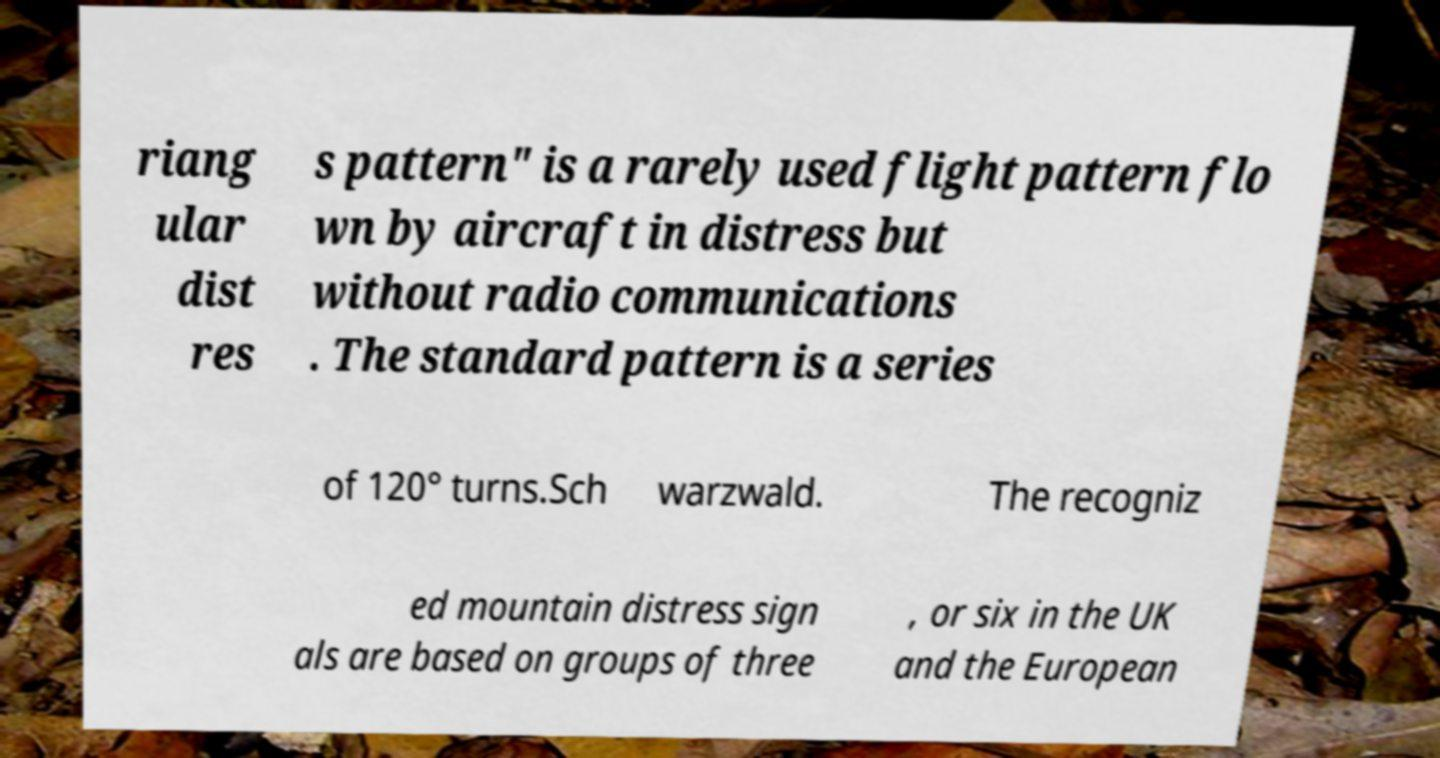There's text embedded in this image that I need extracted. Can you transcribe it verbatim? riang ular dist res s pattern" is a rarely used flight pattern flo wn by aircraft in distress but without radio communications . The standard pattern is a series of 120° turns.Sch warzwald. The recogniz ed mountain distress sign als are based on groups of three , or six in the UK and the European 